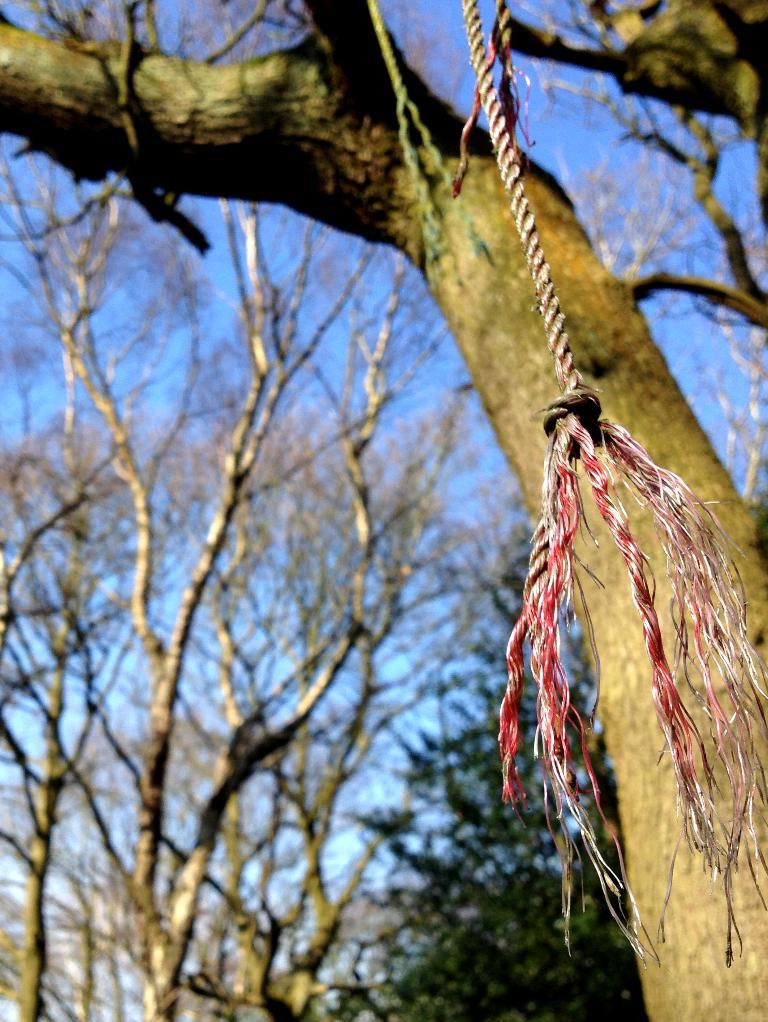What is hanging in the center of the image? There is a rope hanging in the center of the image. What can be seen in the background of the image? There are trees in the background of the image. Where is the nest located in the image? There is no nest present in the image; it only features a rope hanging in the center and trees in the background. 